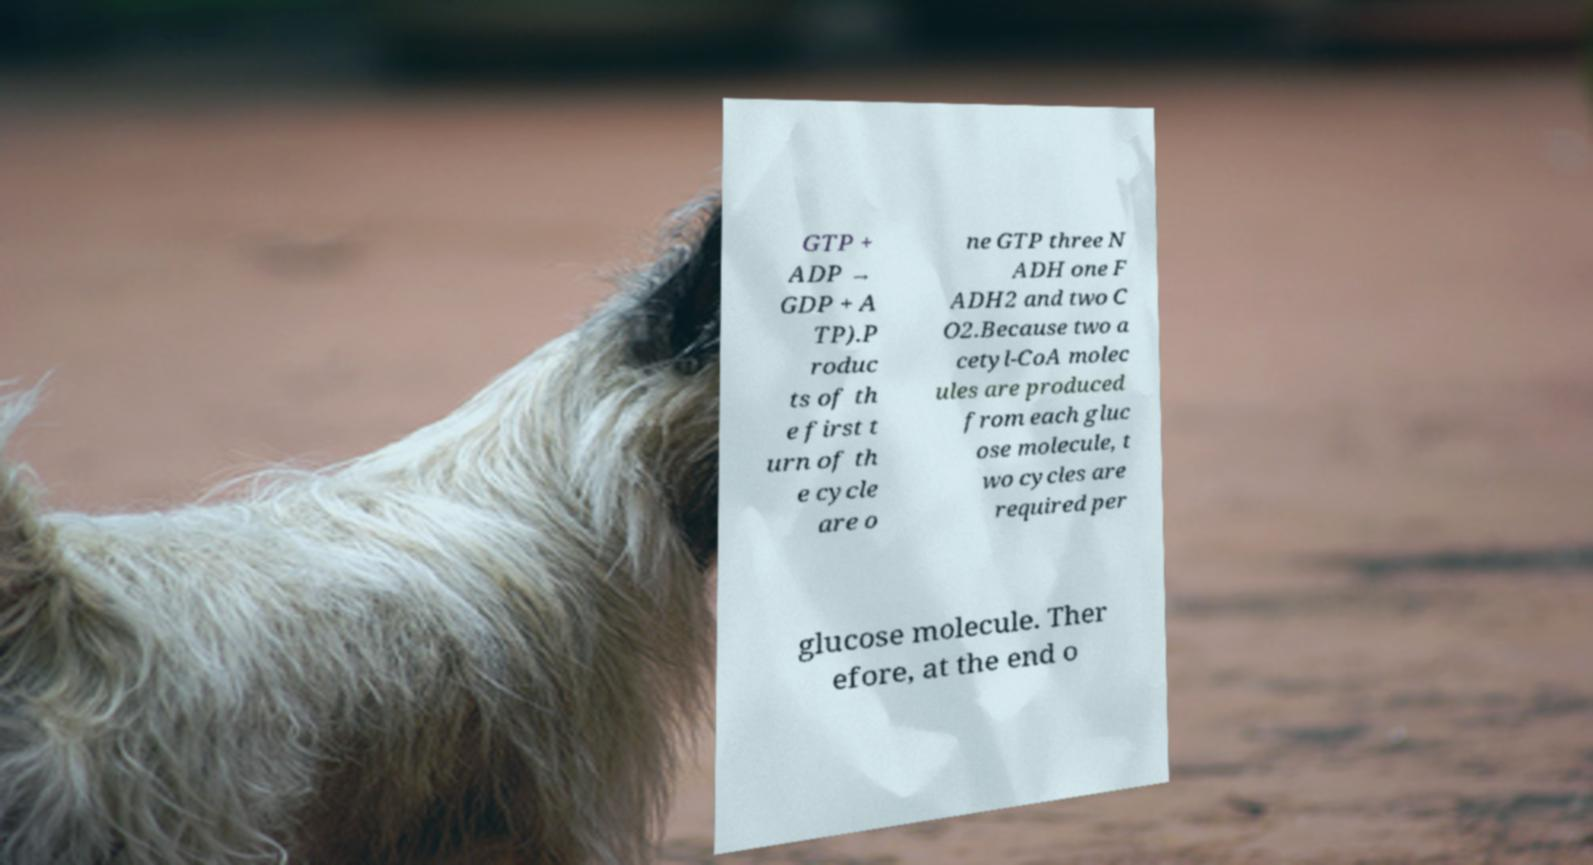For documentation purposes, I need the text within this image transcribed. Could you provide that? GTP + ADP → GDP + A TP).P roduc ts of th e first t urn of th e cycle are o ne GTP three N ADH one F ADH2 and two C O2.Because two a cetyl-CoA molec ules are produced from each gluc ose molecule, t wo cycles are required per glucose molecule. Ther efore, at the end o 